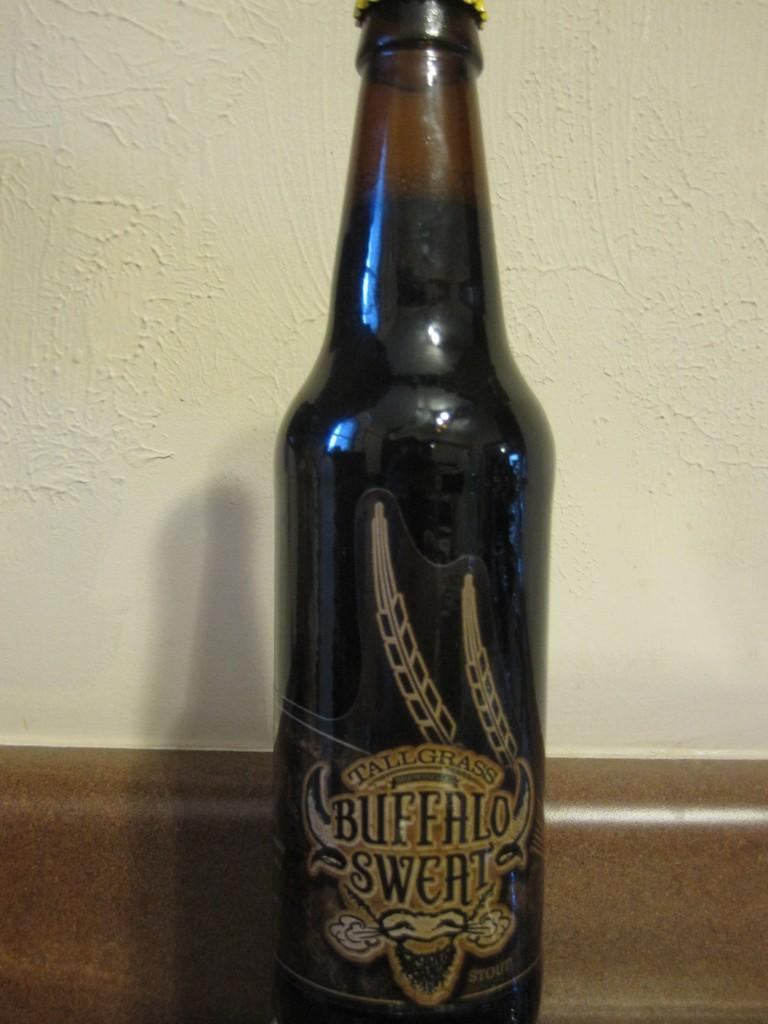<image>
Describe the image concisely. Bottle of Tallgrass Buffalo Sweat beer sitting on a table 